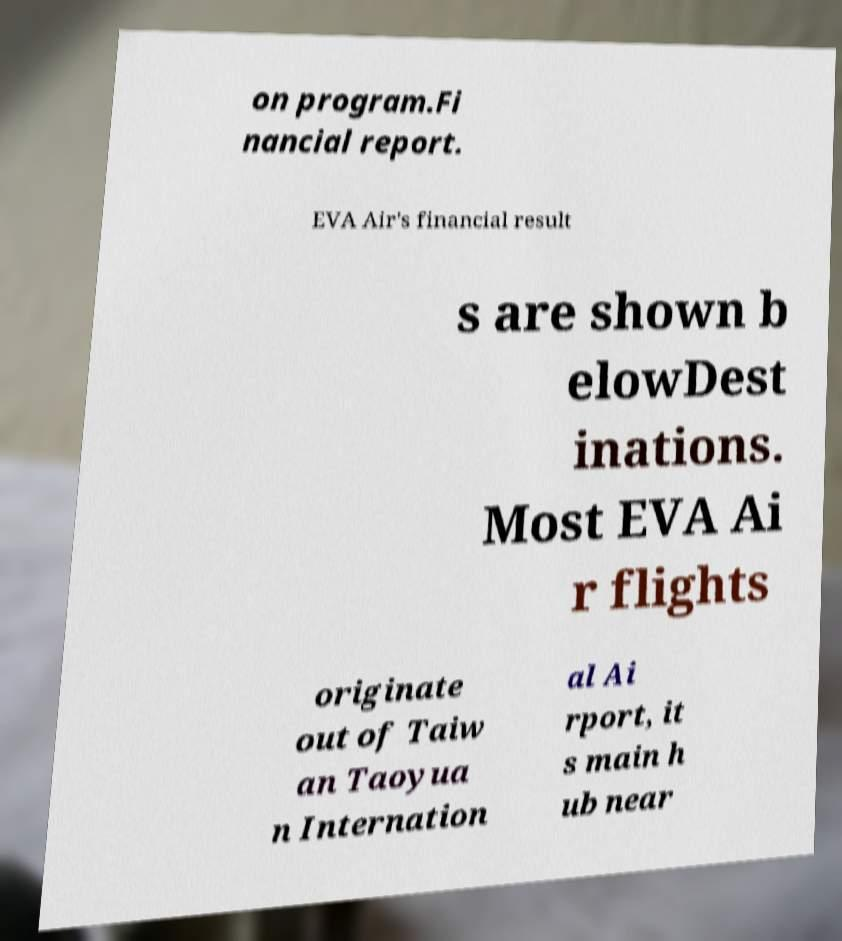Could you extract and type out the text from this image? on program.Fi nancial report. EVA Air's financial result s are shown b elowDest inations. Most EVA Ai r flights originate out of Taiw an Taoyua n Internation al Ai rport, it s main h ub near 